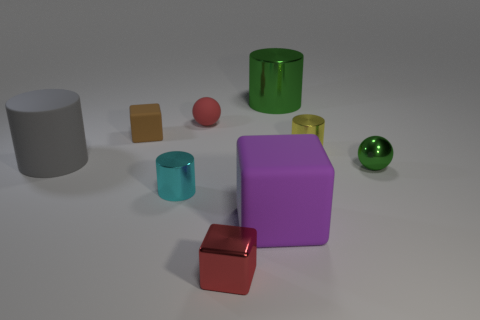Are the big green cylinder and the red object behind the small brown matte object made of the same material?
Keep it short and to the point. No. There is a large cylinder that is the same color as the metallic ball; what is it made of?
Provide a short and direct response. Metal. Do the small rubber ball and the metal cube have the same color?
Offer a very short reply. Yes. There is a small red thing in front of the tiny metallic cylinder to the right of the green metal thing on the left side of the small yellow object; what is its material?
Offer a very short reply. Metal. Do the green sphere behind the purple cube and the yellow thing have the same size?
Provide a succinct answer. Yes. There is a tiny red thing that is in front of the yellow thing; what is its material?
Keep it short and to the point. Metal. Are there more small red objects than large objects?
Offer a terse response. No. How many objects are cylinders that are in front of the big metallic object or cyan metal things?
Make the answer very short. 3. How many purple blocks are behind the cylinder that is behind the yellow metallic cylinder?
Provide a short and direct response. 0. What is the size of the sphere in front of the tiny ball on the left side of the thing that is behind the tiny red matte thing?
Your answer should be very brief. Small. 